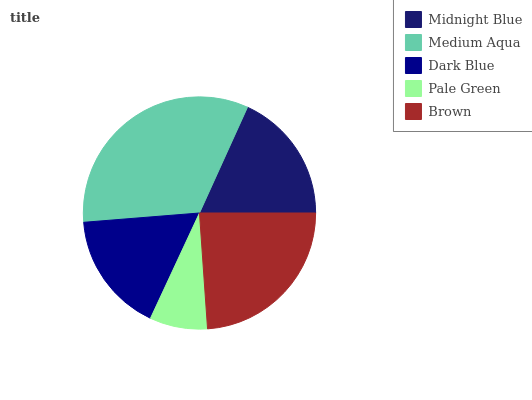Is Pale Green the minimum?
Answer yes or no. Yes. Is Medium Aqua the maximum?
Answer yes or no. Yes. Is Dark Blue the minimum?
Answer yes or no. No. Is Dark Blue the maximum?
Answer yes or no. No. Is Medium Aqua greater than Dark Blue?
Answer yes or no. Yes. Is Dark Blue less than Medium Aqua?
Answer yes or no. Yes. Is Dark Blue greater than Medium Aqua?
Answer yes or no. No. Is Medium Aqua less than Dark Blue?
Answer yes or no. No. Is Midnight Blue the high median?
Answer yes or no. Yes. Is Midnight Blue the low median?
Answer yes or no. Yes. Is Brown the high median?
Answer yes or no. No. Is Brown the low median?
Answer yes or no. No. 